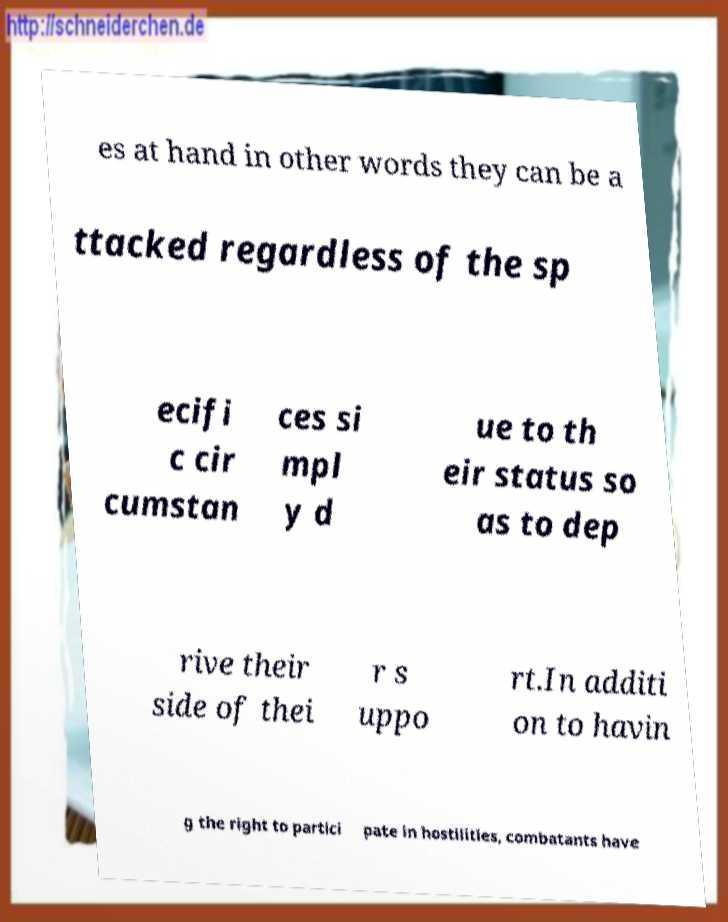Please identify and transcribe the text found in this image. es at hand in other words they can be a ttacked regardless of the sp ecifi c cir cumstan ces si mpl y d ue to th eir status so as to dep rive their side of thei r s uppo rt.In additi on to havin g the right to partici pate in hostilities, combatants have 